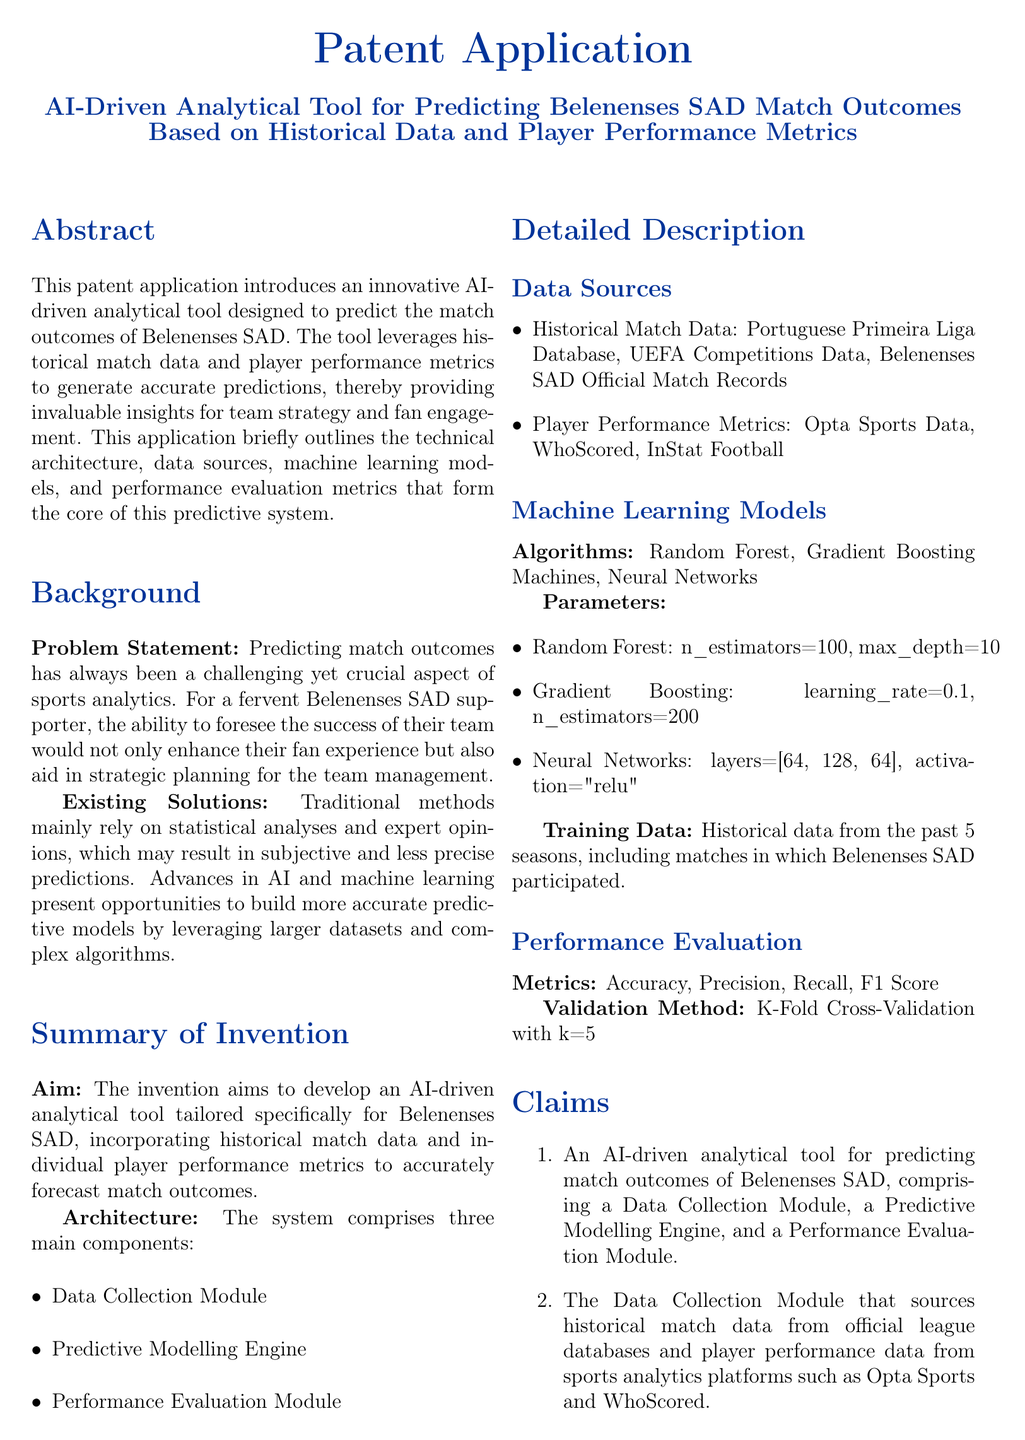what is the title of the patent application? The title of the patent application is explicitly stated at the beginning of the document.
Answer: AI-Driven Analytical Tool for Predicting Belenenses SAD Match Outcomes Based on Historical Data and Player Performance Metrics what is the problem statement addressed in the patent application? The problem statement is provided in the background section, detailing the challenge faced by supporters in predicting match outcomes.
Answer: Predicting match outcomes has always been a challenging yet crucial aspect of sports analytics what are the three main components of the system architecture? The three main components are listed in the summary of invention section.
Answer: Data Collection Module, Predictive Modelling Engine, Performance Evaluation Module which league's historical data is utilized for predictions? The specific leagues from which historical data is sourced are mentioned in the data sources subsection.
Answer: Portuguese Primeira Liga Database how many seasons of data are used for training the models? This information is found in the detailed description section concerning training data.
Answer: 5 seasons what machine learning algorithms are employed in the predictive modeling engine? The algorithms used for predictions are listed in the machine learning models subsection.
Answer: Random Forest, Gradient Boosting Machines, Neural Networks what is the validation method used for performance evaluation? The validation method is described under the performance evaluation section.
Answer: K-Fold Cross-Validation with k=5 what performance metrics are specified for evaluating the models? The metrics employed for evaluating model performance are outlined in the performance evaluation section.
Answer: Accuracy, Precision, Recall, F1 Score what is the aim of the invention? The aim of the invention is mentioned in the summary of invention section.
Answer: To develop an AI-driven analytical tool tailored specifically for Belenenses SAD 